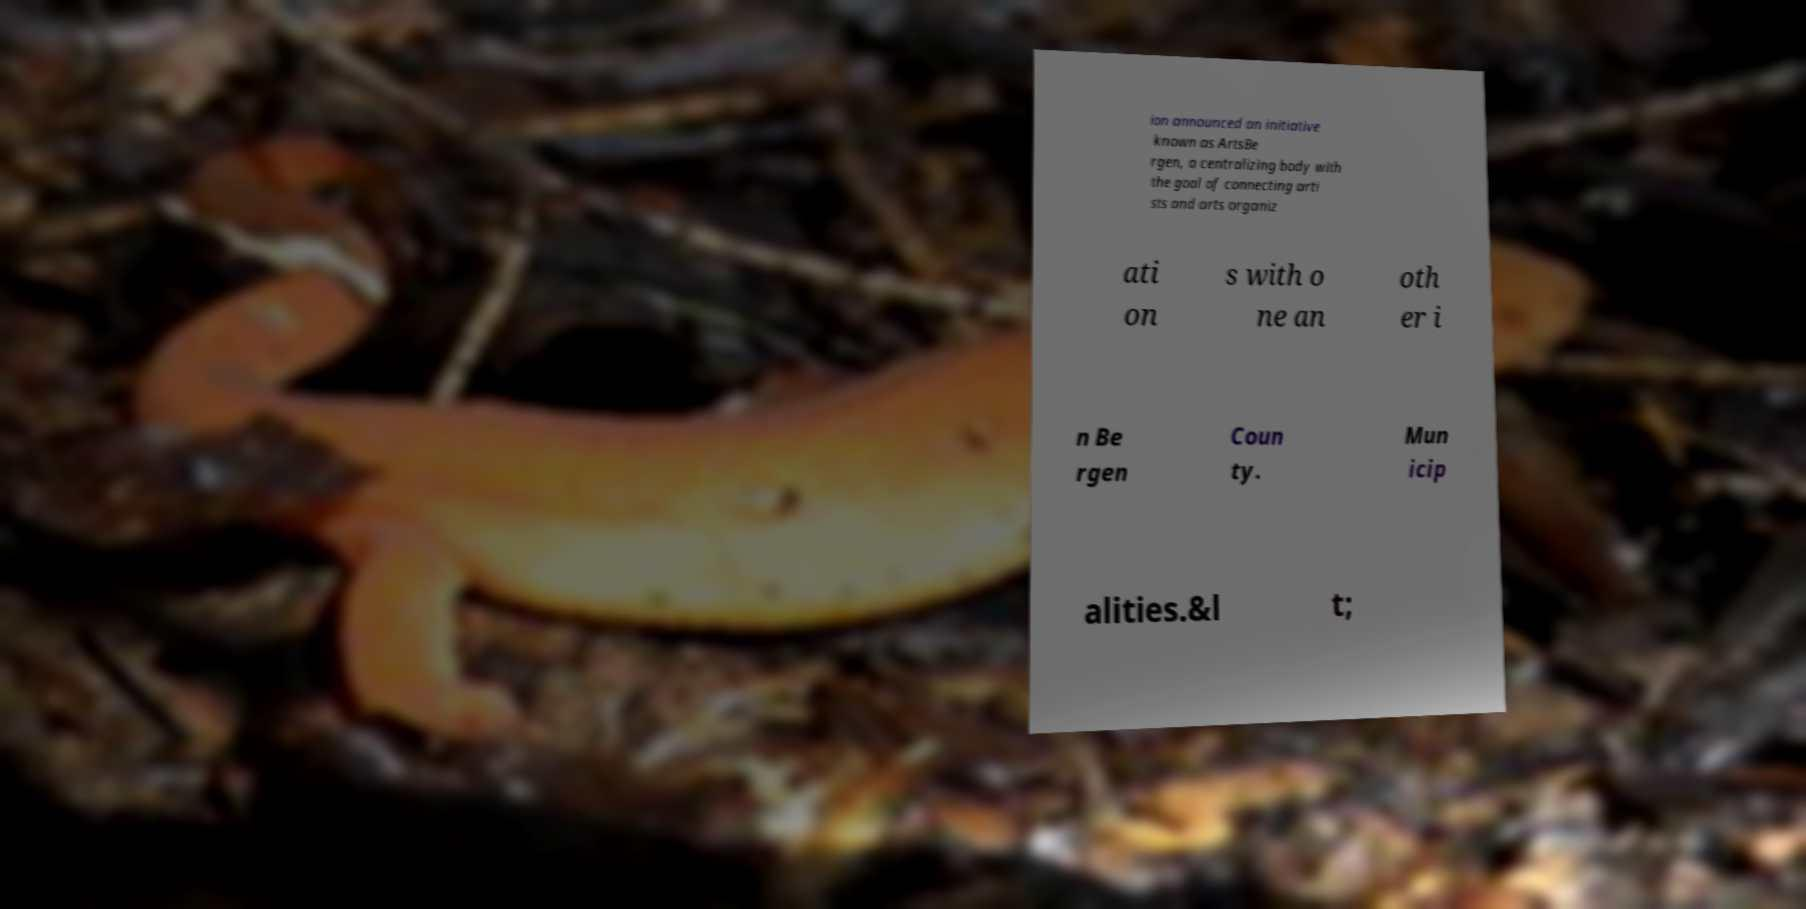For documentation purposes, I need the text within this image transcribed. Could you provide that? ion announced an initiative known as ArtsBe rgen, a centralizing body with the goal of connecting arti sts and arts organiz ati on s with o ne an oth er i n Be rgen Coun ty. Mun icip alities.&l t; 